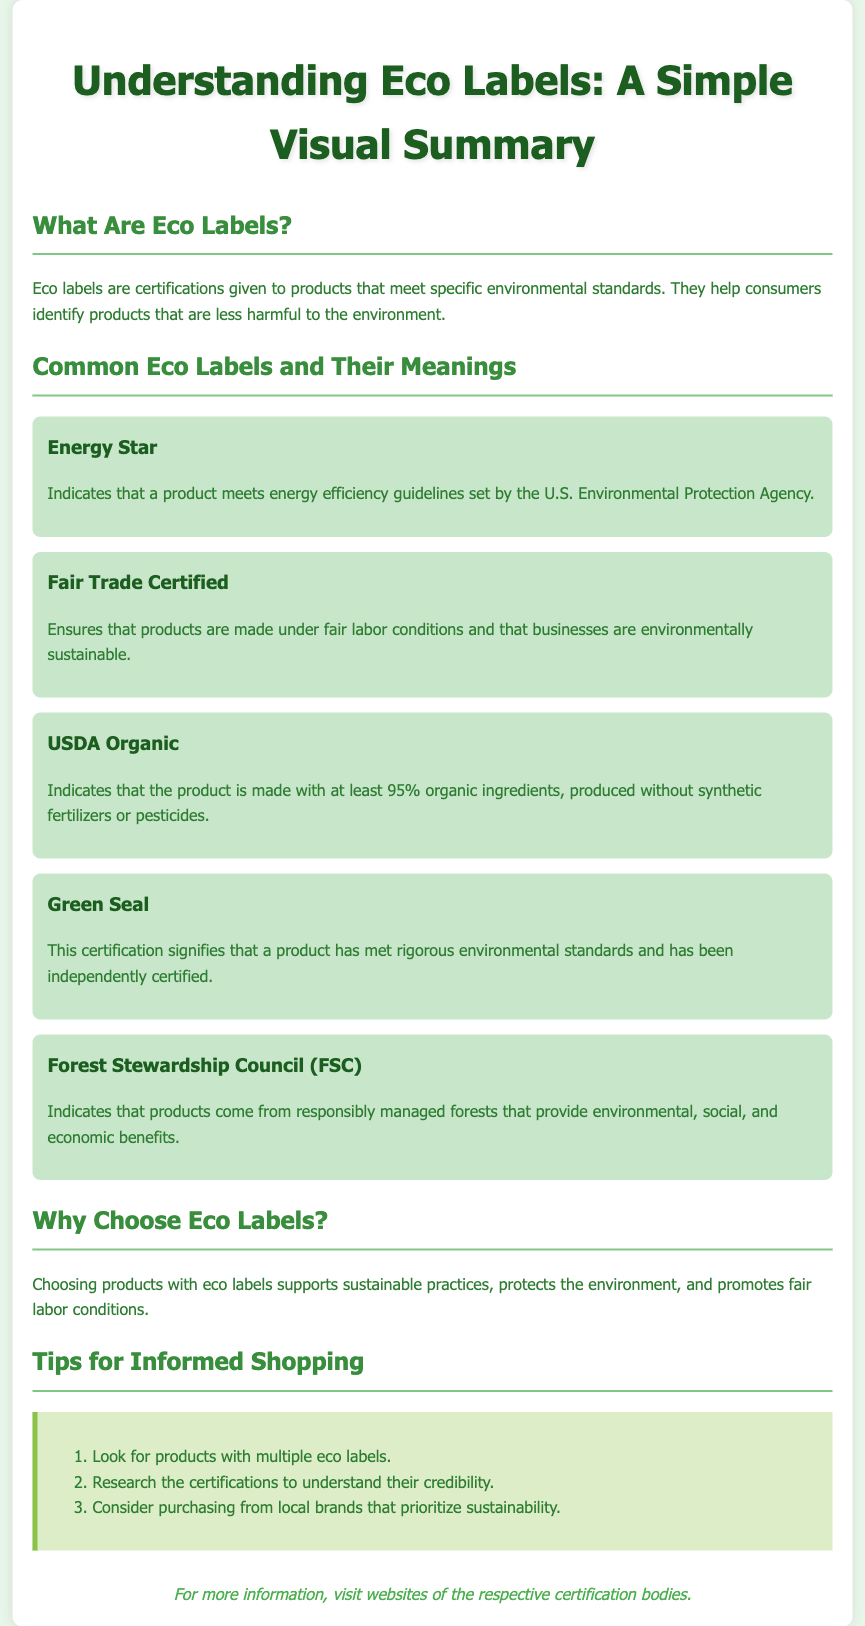What are eco labels? Eco labels are certifications given to products that meet specific environmental standards.
Answer: Certifications given to products that meet specific environmental standards What does the Energy Star label signify? Indicates that a product meets energy efficiency guidelines set by the U.S. Environmental Protection Agency.
Answer: Energy efficiency guidelines What is the minimum percentage of organic ingredients required for USDA Organic certification? The document states that the product must be made with at least 95% organic ingredients.
Answer: 95% What does Fair Trade Certified ensure? Ensures that products are made under fair labor conditions and that businesses are environmentally sustainable.
Answer: Fair labor conditions and environmental sustainability Why should consumers choose eco labels? Choosing products with eco labels supports sustainable practices, protects the environment, and promotes fair labor conditions.
Answer: Supports sustainable practices What is one of the tips for informed shopping? Look for products with multiple eco labels is mentioned as a tip.
Answer: Look for products with multiple eco labels What organization is responsible for the Energy Star label? The U.S. Environmental Protection Agency is the organization responsible for it.
Answer: U.S. Environmental Protection Agency 